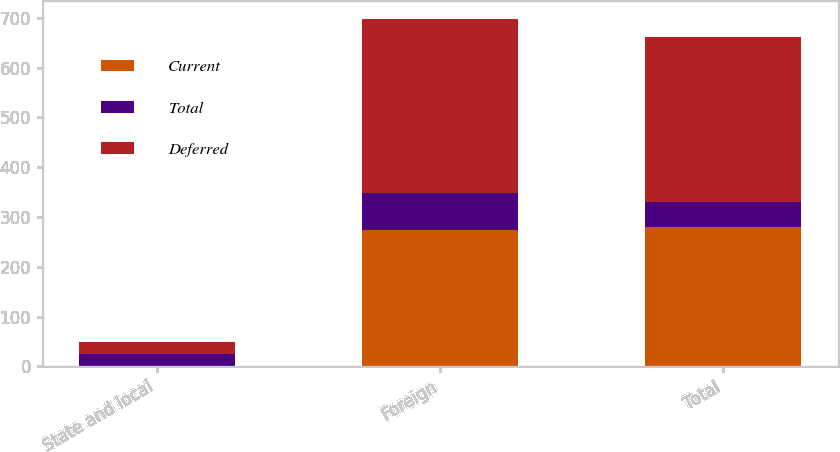Convert chart to OTSL. <chart><loc_0><loc_0><loc_500><loc_500><stacked_bar_chart><ecel><fcel>State and local<fcel>Foreign<fcel>Total<nl><fcel>Current<fcel>1<fcel>274<fcel>279<nl><fcel>Total<fcel>23<fcel>75<fcel>52<nl><fcel>Deferred<fcel>24<fcel>349<fcel>331<nl></chart> 